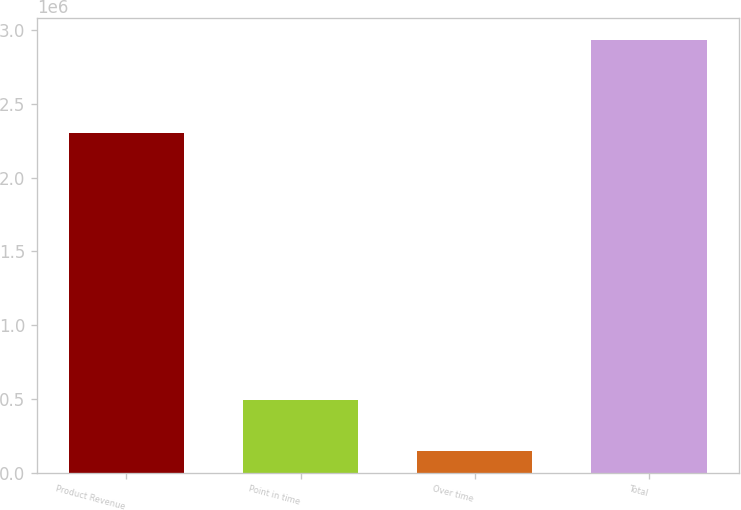<chart> <loc_0><loc_0><loc_500><loc_500><bar_chart><fcel>Product Revenue<fcel>Point in time<fcel>Over time<fcel>Total<nl><fcel>2.30008e+06<fcel>488962<fcel>146549<fcel>2.93559e+06<nl></chart> 